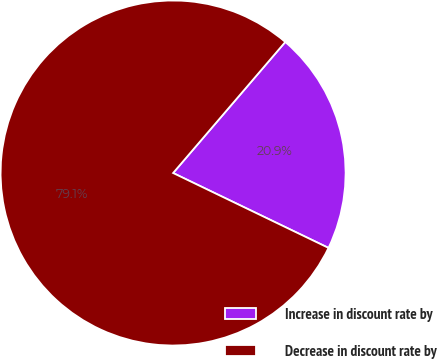Convert chart to OTSL. <chart><loc_0><loc_0><loc_500><loc_500><pie_chart><fcel>Increase in discount rate by<fcel>Decrease in discount rate by<nl><fcel>20.88%<fcel>79.12%<nl></chart> 